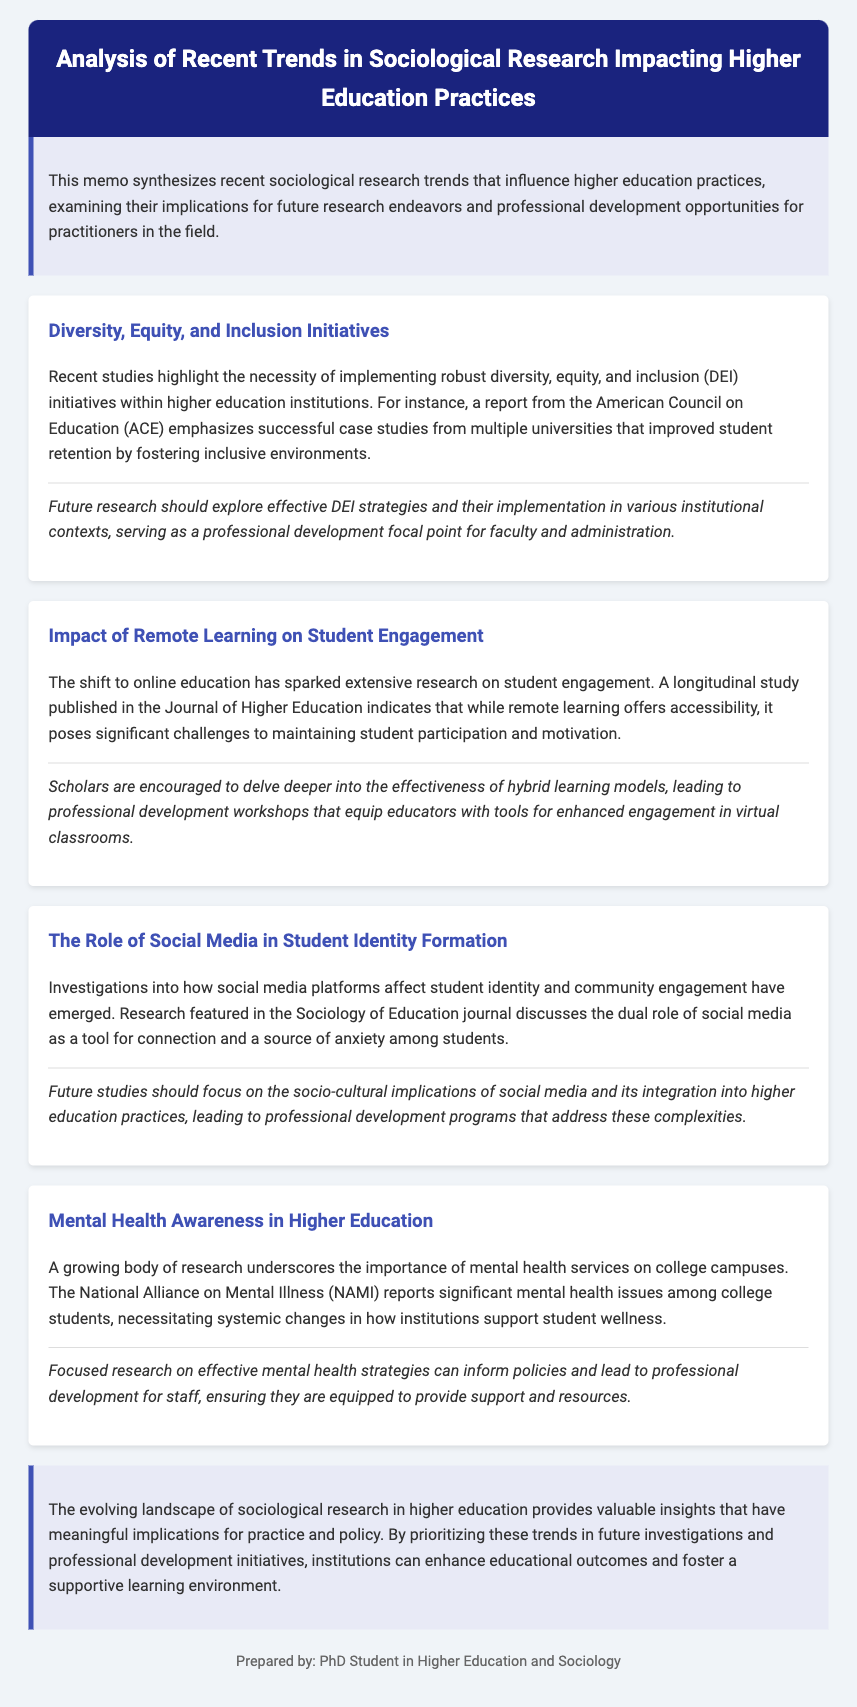What is the main focus of the memo? The memo synthesizes recent sociological research trends that influence higher education practices.
Answer: Sociological research trends Which initiative is highlighted as necessary in the document? The document emphasizes the importance of implementing robust diversity, equity, and inclusion initiatives.
Answer: Diversity, equity, and inclusion What does the longitudinal study mentioned in the document focus on? It focuses on the impact of remote learning on student engagement.
Answer: Remote learning How many trends are analyzed in the memo? The memo discusses four main trends impacting higher education practices.
Answer: Four What issue does the National Alliance on Mental Illness (NAMI) report address? It reports on significant mental health issues among college students.
Answer: Mental health issues What type of professional development is suggested for enhanced engagement in virtual classrooms? The document suggests workshops that equip educators with tools for engagement.
Answer: Professional development workshops What role does social media play according to the research? Social media is discussed as a tool for connection and a source of anxiety among students.
Answer: Connection and anxiety What should future studies focus on according to the memo? Future studies should focus on the socio-cultural implications of social media.
Answer: Socio-cultural implications Who prepared the memo? The memo is prepared by a PhD student in Higher Education and Sociology.
Answer: PhD Student in Higher Education and Sociology 